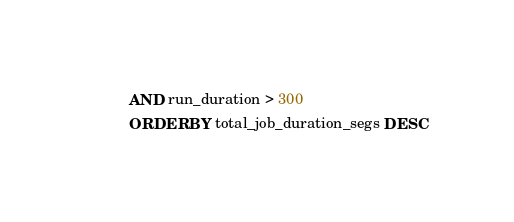<code> <loc_0><loc_0><loc_500><loc_500><_SQL_>AND run_duration > 300
ORDER BY total_job_duration_segs DESC
</code> 